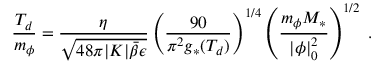<formula> <loc_0><loc_0><loc_500><loc_500>\frac { T _ { d } } { m _ { \phi } } = \frac { \eta } { \sqrt { 4 8 \pi | K | \bar { \beta } \epsilon } } \left ( \frac { 9 0 } { \pi ^ { 2 } g _ { * } ( T _ { d } ) } \right ) ^ { 1 / 4 } \left ( \frac { m _ { \phi } M _ { * } } { | \phi | _ { 0 } ^ { 2 } } \right ) ^ { 1 / 2 } \, .</formula> 